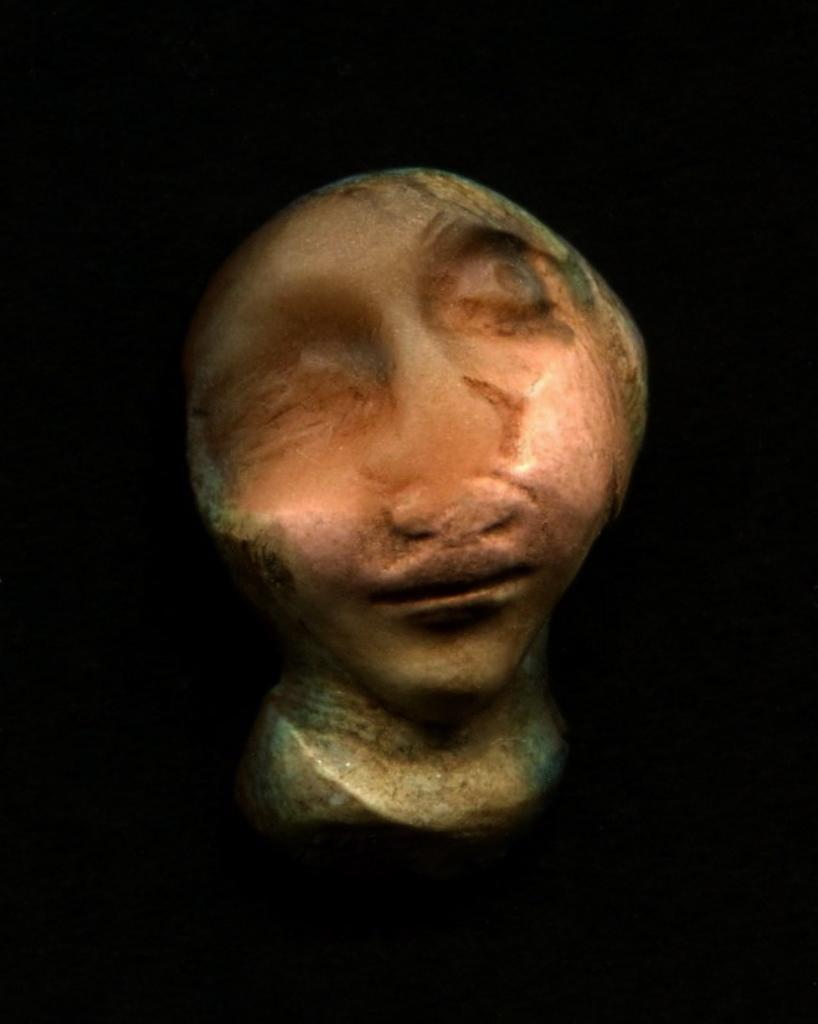How would you summarize this image in a sentence or two? This picture is consists of a bust in the image. 